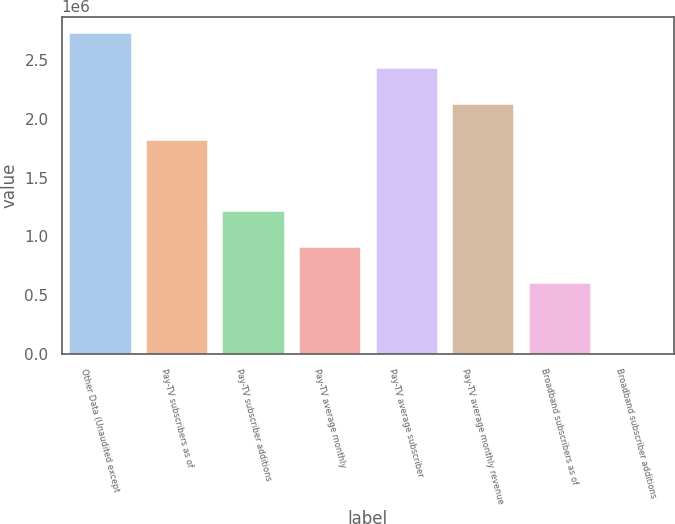Convert chart. <chart><loc_0><loc_0><loc_500><loc_500><bar_chart><fcel>Other Data (Unaudited except<fcel>Pay-TV subscribers as of<fcel>Pay-TV subscriber additions<fcel>Pay-TV average monthly<fcel>Pay-TV average subscriber<fcel>Pay-TV average monthly revenue<fcel>Broadband subscribers as of<fcel>Broadband subscriber additions<nl><fcel>2.73137e+06<fcel>1.82091e+06<fcel>1.21394e+06<fcel>910457<fcel>2.42789e+06<fcel>2.1244e+06<fcel>606972<fcel>0.25<nl></chart> 